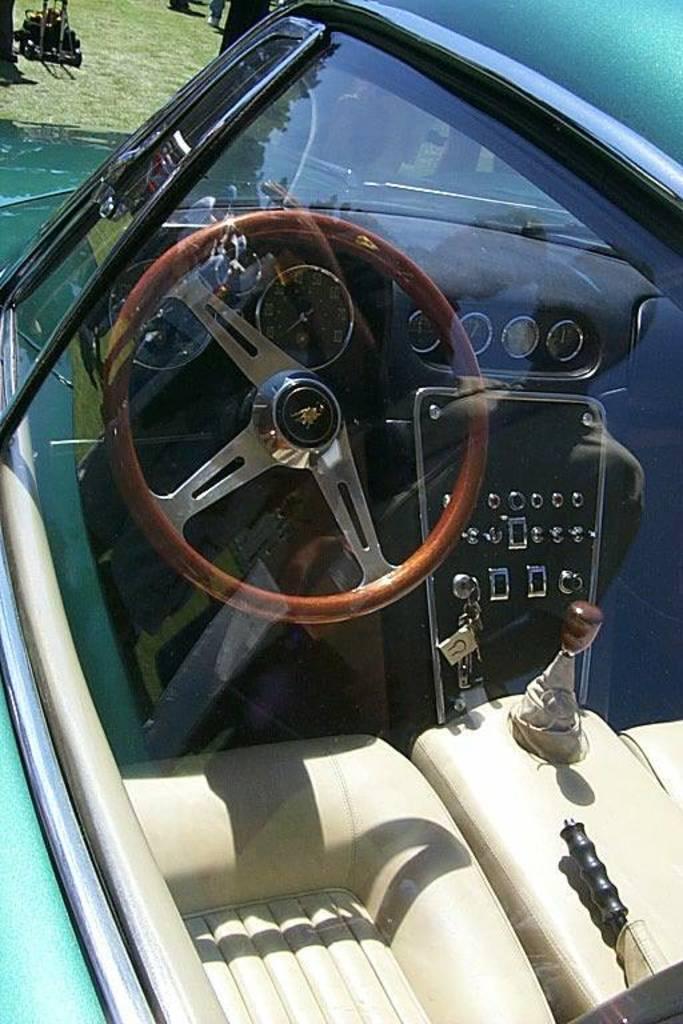Could you give a brief overview of what you see in this image? This is a car. Through the glass we can see seats, gear, keys, meters and steering. At the top there's grass on the ground. 